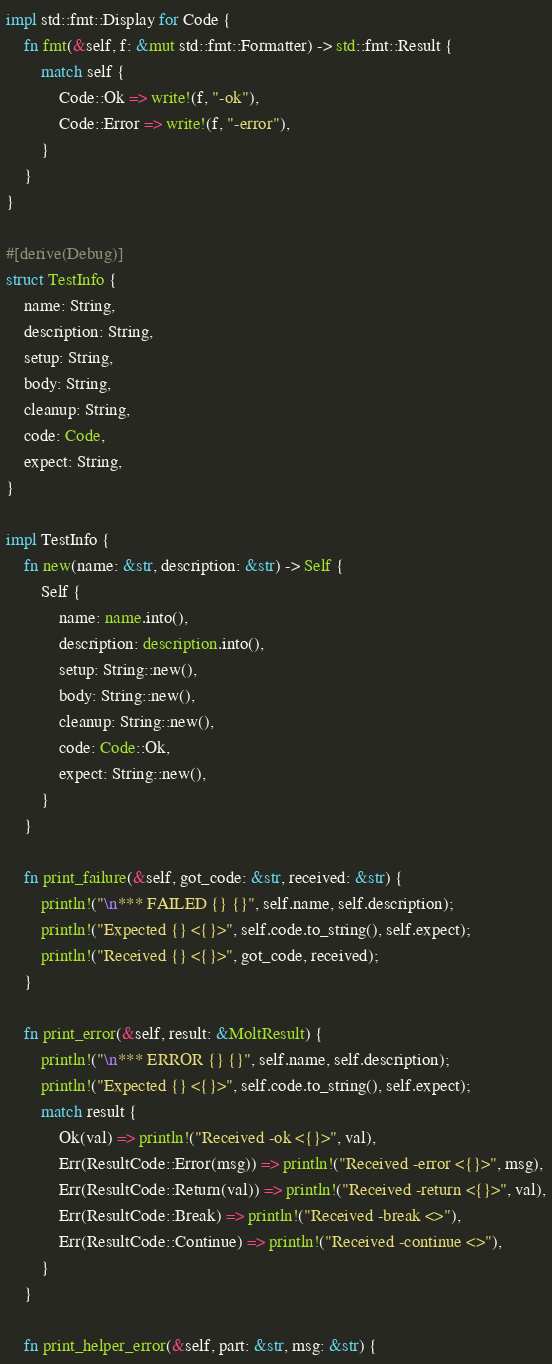Convert code to text. <code><loc_0><loc_0><loc_500><loc_500><_Rust_>
impl std::fmt::Display for Code {
    fn fmt(&self, f: &mut std::fmt::Formatter) -> std::fmt::Result {
        match self {
            Code::Ok => write!(f, "-ok"),
            Code::Error => write!(f, "-error"),
        }
    }
}

#[derive(Debug)]
struct TestInfo {
    name: String,
    description: String,
    setup: String,
    body: String,
    cleanup: String,
    code: Code,
    expect: String,
}

impl TestInfo {
    fn new(name: &str, description: &str) -> Self {
        Self {
            name: name.into(),
            description: description.into(),
            setup: String::new(),
            body: String::new(),
            cleanup: String::new(),
            code: Code::Ok,
            expect: String::new(),
        }
    }

    fn print_failure(&self, got_code: &str, received: &str) {
        println!("\n*** FAILED {} {}", self.name, self.description);
        println!("Expected {} <{}>", self.code.to_string(), self.expect);
        println!("Received {} <{}>", got_code, received);
    }

    fn print_error(&self, result: &MoltResult) {
        println!("\n*** ERROR {} {}", self.name, self.description);
        println!("Expected {} <{}>", self.code.to_string(), self.expect);
        match result {
            Ok(val) => println!("Received -ok <{}>", val),
            Err(ResultCode::Error(msg)) => println!("Received -error <{}>", msg),
            Err(ResultCode::Return(val)) => println!("Received -return <{}>", val),
            Err(ResultCode::Break) => println!("Received -break <>"),
            Err(ResultCode::Continue) => println!("Received -continue <>"),
        }
    }

    fn print_helper_error(&self, part: &str, msg: &str) {</code> 